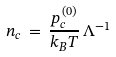<formula> <loc_0><loc_0><loc_500><loc_500>n _ { c } \, = \, \frac { p _ { c } ^ { \, ( 0 ) } } { k _ { B } T } \, \Lambda ^ { - 1 }</formula> 